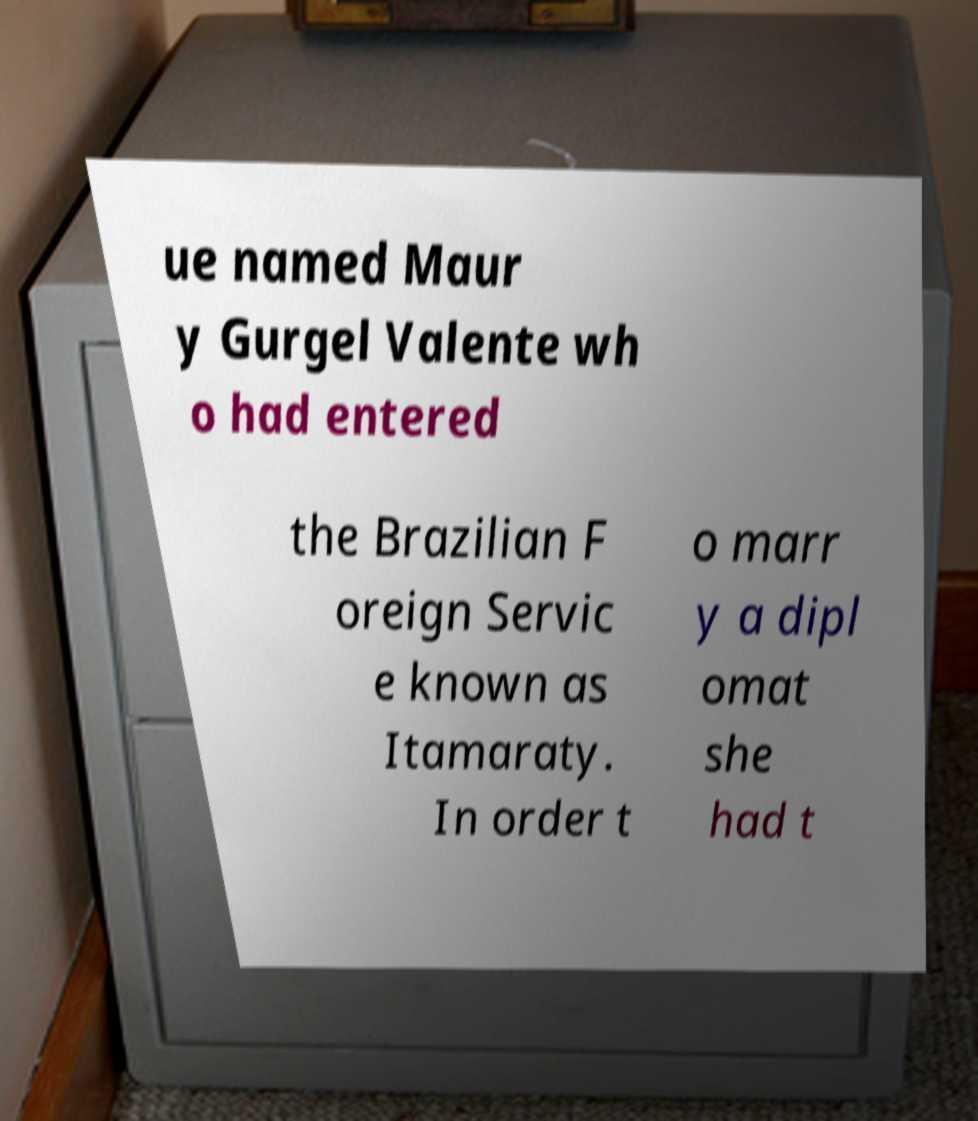Could you assist in decoding the text presented in this image and type it out clearly? ue named Maur y Gurgel Valente wh o had entered the Brazilian F oreign Servic e known as Itamaraty. In order t o marr y a dipl omat she had t 